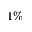<formula> <loc_0><loc_0><loc_500><loc_500>1 \%</formula> 